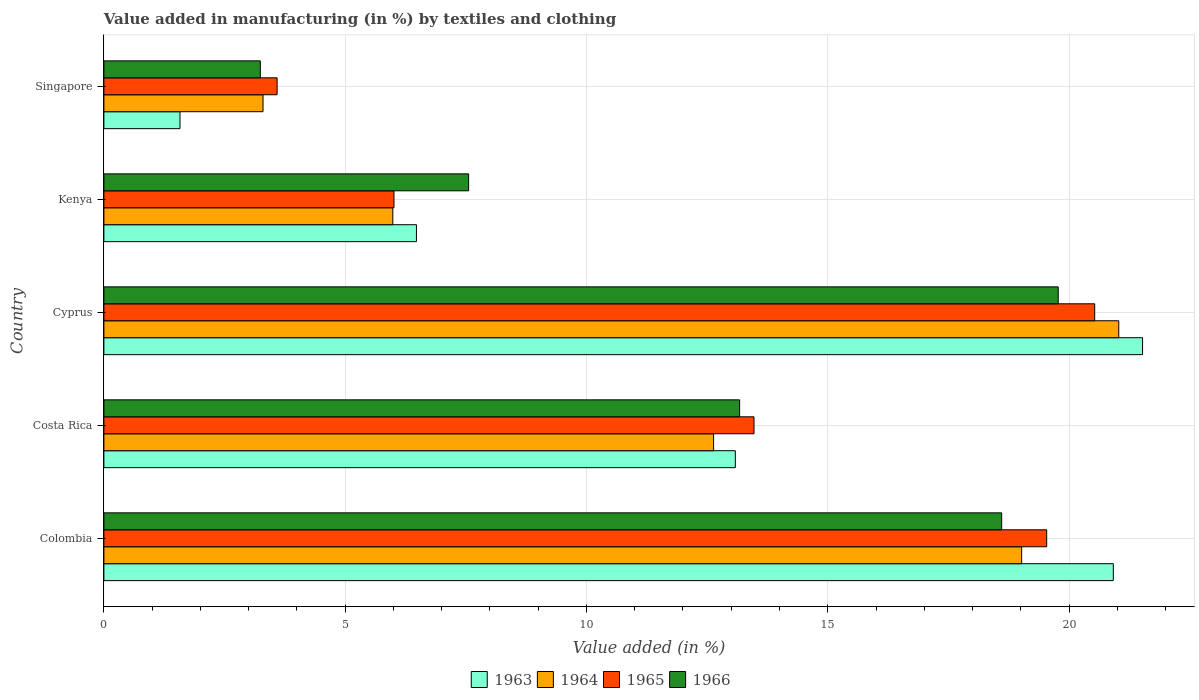How many different coloured bars are there?
Give a very brief answer. 4. How many groups of bars are there?
Your answer should be very brief. 5. Are the number of bars on each tick of the Y-axis equal?
Provide a succinct answer. Yes. How many bars are there on the 1st tick from the top?
Keep it short and to the point. 4. How many bars are there on the 3rd tick from the bottom?
Provide a succinct answer. 4. What is the percentage of value added in manufacturing by textiles and clothing in 1964 in Colombia?
Your response must be concise. 19.02. Across all countries, what is the maximum percentage of value added in manufacturing by textiles and clothing in 1965?
Keep it short and to the point. 20.53. Across all countries, what is the minimum percentage of value added in manufacturing by textiles and clothing in 1966?
Offer a very short reply. 3.24. In which country was the percentage of value added in manufacturing by textiles and clothing in 1965 maximum?
Your response must be concise. Cyprus. In which country was the percentage of value added in manufacturing by textiles and clothing in 1964 minimum?
Offer a terse response. Singapore. What is the total percentage of value added in manufacturing by textiles and clothing in 1966 in the graph?
Give a very brief answer. 62.35. What is the difference between the percentage of value added in manufacturing by textiles and clothing in 1966 in Colombia and that in Singapore?
Make the answer very short. 15.36. What is the difference between the percentage of value added in manufacturing by textiles and clothing in 1964 in Kenya and the percentage of value added in manufacturing by textiles and clothing in 1965 in Singapore?
Your response must be concise. 2.4. What is the average percentage of value added in manufacturing by textiles and clothing in 1964 per country?
Your answer should be compact. 12.39. What is the difference between the percentage of value added in manufacturing by textiles and clothing in 1966 and percentage of value added in manufacturing by textiles and clothing in 1964 in Kenya?
Make the answer very short. 1.57. In how many countries, is the percentage of value added in manufacturing by textiles and clothing in 1966 greater than 1 %?
Offer a very short reply. 5. What is the ratio of the percentage of value added in manufacturing by textiles and clothing in 1964 in Kenya to that in Singapore?
Provide a succinct answer. 1.82. What is the difference between the highest and the second highest percentage of value added in manufacturing by textiles and clothing in 1965?
Ensure brevity in your answer.  0.99. What is the difference between the highest and the lowest percentage of value added in manufacturing by textiles and clothing in 1963?
Offer a terse response. 19.95. In how many countries, is the percentage of value added in manufacturing by textiles and clothing in 1963 greater than the average percentage of value added in manufacturing by textiles and clothing in 1963 taken over all countries?
Provide a succinct answer. 3. Is the sum of the percentage of value added in manufacturing by textiles and clothing in 1964 in Kenya and Singapore greater than the maximum percentage of value added in manufacturing by textiles and clothing in 1966 across all countries?
Your answer should be compact. No. What does the 3rd bar from the top in Singapore represents?
Your answer should be very brief. 1964. What does the 4th bar from the bottom in Kenya represents?
Keep it short and to the point. 1966. How many bars are there?
Make the answer very short. 20. How many countries are there in the graph?
Provide a succinct answer. 5. What is the difference between two consecutive major ticks on the X-axis?
Ensure brevity in your answer.  5. Does the graph contain any zero values?
Provide a short and direct response. No. Does the graph contain grids?
Your answer should be very brief. Yes. Where does the legend appear in the graph?
Your answer should be very brief. Bottom center. How many legend labels are there?
Your answer should be very brief. 4. What is the title of the graph?
Give a very brief answer. Value added in manufacturing (in %) by textiles and clothing. Does "1983" appear as one of the legend labels in the graph?
Make the answer very short. No. What is the label or title of the X-axis?
Provide a succinct answer. Value added (in %). What is the Value added (in %) of 1963 in Colombia?
Your response must be concise. 20.92. What is the Value added (in %) of 1964 in Colombia?
Provide a succinct answer. 19.02. What is the Value added (in %) in 1965 in Colombia?
Make the answer very short. 19.54. What is the Value added (in %) in 1966 in Colombia?
Your answer should be very brief. 18.6. What is the Value added (in %) in 1963 in Costa Rica?
Ensure brevity in your answer.  13.08. What is the Value added (in %) of 1964 in Costa Rica?
Give a very brief answer. 12.63. What is the Value added (in %) in 1965 in Costa Rica?
Ensure brevity in your answer.  13.47. What is the Value added (in %) in 1966 in Costa Rica?
Provide a short and direct response. 13.17. What is the Value added (in %) of 1963 in Cyprus?
Keep it short and to the point. 21.52. What is the Value added (in %) in 1964 in Cyprus?
Ensure brevity in your answer.  21.03. What is the Value added (in %) of 1965 in Cyprus?
Your answer should be very brief. 20.53. What is the Value added (in %) in 1966 in Cyprus?
Offer a terse response. 19.78. What is the Value added (in %) of 1963 in Kenya?
Keep it short and to the point. 6.48. What is the Value added (in %) in 1964 in Kenya?
Make the answer very short. 5.99. What is the Value added (in %) of 1965 in Kenya?
Keep it short and to the point. 6.01. What is the Value added (in %) of 1966 in Kenya?
Your response must be concise. 7.56. What is the Value added (in %) in 1963 in Singapore?
Provide a short and direct response. 1.58. What is the Value added (in %) in 1964 in Singapore?
Make the answer very short. 3.3. What is the Value added (in %) of 1965 in Singapore?
Ensure brevity in your answer.  3.59. What is the Value added (in %) of 1966 in Singapore?
Offer a terse response. 3.24. Across all countries, what is the maximum Value added (in %) of 1963?
Provide a succinct answer. 21.52. Across all countries, what is the maximum Value added (in %) of 1964?
Keep it short and to the point. 21.03. Across all countries, what is the maximum Value added (in %) of 1965?
Offer a very short reply. 20.53. Across all countries, what is the maximum Value added (in %) in 1966?
Provide a succinct answer. 19.78. Across all countries, what is the minimum Value added (in %) of 1963?
Give a very brief answer. 1.58. Across all countries, what is the minimum Value added (in %) in 1964?
Your response must be concise. 3.3. Across all countries, what is the minimum Value added (in %) in 1965?
Ensure brevity in your answer.  3.59. Across all countries, what is the minimum Value added (in %) in 1966?
Your answer should be compact. 3.24. What is the total Value added (in %) in 1963 in the graph?
Your answer should be very brief. 63.58. What is the total Value added (in %) of 1964 in the graph?
Provide a short and direct response. 61.97. What is the total Value added (in %) in 1965 in the graph?
Provide a short and direct response. 63.14. What is the total Value added (in %) of 1966 in the graph?
Give a very brief answer. 62.35. What is the difference between the Value added (in %) of 1963 in Colombia and that in Costa Rica?
Offer a very short reply. 7.83. What is the difference between the Value added (in %) in 1964 in Colombia and that in Costa Rica?
Provide a short and direct response. 6.38. What is the difference between the Value added (in %) in 1965 in Colombia and that in Costa Rica?
Your response must be concise. 6.06. What is the difference between the Value added (in %) in 1966 in Colombia and that in Costa Rica?
Your response must be concise. 5.43. What is the difference between the Value added (in %) of 1963 in Colombia and that in Cyprus?
Offer a very short reply. -0.61. What is the difference between the Value added (in %) of 1964 in Colombia and that in Cyprus?
Provide a short and direct response. -2.01. What is the difference between the Value added (in %) in 1965 in Colombia and that in Cyprus?
Give a very brief answer. -0.99. What is the difference between the Value added (in %) in 1966 in Colombia and that in Cyprus?
Give a very brief answer. -1.17. What is the difference between the Value added (in %) in 1963 in Colombia and that in Kenya?
Give a very brief answer. 14.44. What is the difference between the Value added (in %) of 1964 in Colombia and that in Kenya?
Make the answer very short. 13.03. What is the difference between the Value added (in %) in 1965 in Colombia and that in Kenya?
Offer a very short reply. 13.53. What is the difference between the Value added (in %) in 1966 in Colombia and that in Kenya?
Make the answer very short. 11.05. What is the difference between the Value added (in %) in 1963 in Colombia and that in Singapore?
Offer a terse response. 19.34. What is the difference between the Value added (in %) in 1964 in Colombia and that in Singapore?
Your answer should be compact. 15.72. What is the difference between the Value added (in %) in 1965 in Colombia and that in Singapore?
Give a very brief answer. 15.95. What is the difference between the Value added (in %) in 1966 in Colombia and that in Singapore?
Offer a very short reply. 15.36. What is the difference between the Value added (in %) in 1963 in Costa Rica and that in Cyprus?
Your answer should be very brief. -8.44. What is the difference between the Value added (in %) of 1964 in Costa Rica and that in Cyprus?
Offer a terse response. -8.4. What is the difference between the Value added (in %) of 1965 in Costa Rica and that in Cyprus?
Keep it short and to the point. -7.06. What is the difference between the Value added (in %) of 1966 in Costa Rica and that in Cyprus?
Provide a succinct answer. -6.6. What is the difference between the Value added (in %) of 1963 in Costa Rica and that in Kenya?
Offer a terse response. 6.61. What is the difference between the Value added (in %) in 1964 in Costa Rica and that in Kenya?
Offer a very short reply. 6.65. What is the difference between the Value added (in %) in 1965 in Costa Rica and that in Kenya?
Provide a succinct answer. 7.46. What is the difference between the Value added (in %) in 1966 in Costa Rica and that in Kenya?
Provide a short and direct response. 5.62. What is the difference between the Value added (in %) of 1963 in Costa Rica and that in Singapore?
Your answer should be compact. 11.51. What is the difference between the Value added (in %) in 1964 in Costa Rica and that in Singapore?
Offer a very short reply. 9.34. What is the difference between the Value added (in %) in 1965 in Costa Rica and that in Singapore?
Offer a very short reply. 9.88. What is the difference between the Value added (in %) in 1966 in Costa Rica and that in Singapore?
Provide a short and direct response. 9.93. What is the difference between the Value added (in %) of 1963 in Cyprus and that in Kenya?
Offer a terse response. 15.05. What is the difference between the Value added (in %) in 1964 in Cyprus and that in Kenya?
Give a very brief answer. 15.04. What is the difference between the Value added (in %) of 1965 in Cyprus and that in Kenya?
Your answer should be very brief. 14.52. What is the difference between the Value added (in %) in 1966 in Cyprus and that in Kenya?
Give a very brief answer. 12.22. What is the difference between the Value added (in %) in 1963 in Cyprus and that in Singapore?
Your answer should be compact. 19.95. What is the difference between the Value added (in %) of 1964 in Cyprus and that in Singapore?
Provide a short and direct response. 17.73. What is the difference between the Value added (in %) in 1965 in Cyprus and that in Singapore?
Keep it short and to the point. 16.94. What is the difference between the Value added (in %) in 1966 in Cyprus and that in Singapore?
Offer a terse response. 16.53. What is the difference between the Value added (in %) of 1963 in Kenya and that in Singapore?
Provide a short and direct response. 4.9. What is the difference between the Value added (in %) in 1964 in Kenya and that in Singapore?
Keep it short and to the point. 2.69. What is the difference between the Value added (in %) in 1965 in Kenya and that in Singapore?
Provide a short and direct response. 2.42. What is the difference between the Value added (in %) in 1966 in Kenya and that in Singapore?
Offer a very short reply. 4.32. What is the difference between the Value added (in %) of 1963 in Colombia and the Value added (in %) of 1964 in Costa Rica?
Keep it short and to the point. 8.28. What is the difference between the Value added (in %) in 1963 in Colombia and the Value added (in %) in 1965 in Costa Rica?
Your answer should be compact. 7.44. What is the difference between the Value added (in %) in 1963 in Colombia and the Value added (in %) in 1966 in Costa Rica?
Your answer should be compact. 7.74. What is the difference between the Value added (in %) of 1964 in Colombia and the Value added (in %) of 1965 in Costa Rica?
Keep it short and to the point. 5.55. What is the difference between the Value added (in %) of 1964 in Colombia and the Value added (in %) of 1966 in Costa Rica?
Ensure brevity in your answer.  5.84. What is the difference between the Value added (in %) of 1965 in Colombia and the Value added (in %) of 1966 in Costa Rica?
Your answer should be compact. 6.36. What is the difference between the Value added (in %) in 1963 in Colombia and the Value added (in %) in 1964 in Cyprus?
Your answer should be very brief. -0.11. What is the difference between the Value added (in %) in 1963 in Colombia and the Value added (in %) in 1965 in Cyprus?
Offer a terse response. 0.39. What is the difference between the Value added (in %) in 1963 in Colombia and the Value added (in %) in 1966 in Cyprus?
Your response must be concise. 1.14. What is the difference between the Value added (in %) of 1964 in Colombia and the Value added (in %) of 1965 in Cyprus?
Your response must be concise. -1.51. What is the difference between the Value added (in %) in 1964 in Colombia and the Value added (in %) in 1966 in Cyprus?
Your response must be concise. -0.76. What is the difference between the Value added (in %) in 1965 in Colombia and the Value added (in %) in 1966 in Cyprus?
Ensure brevity in your answer.  -0.24. What is the difference between the Value added (in %) in 1963 in Colombia and the Value added (in %) in 1964 in Kenya?
Make the answer very short. 14.93. What is the difference between the Value added (in %) of 1963 in Colombia and the Value added (in %) of 1965 in Kenya?
Provide a succinct answer. 14.91. What is the difference between the Value added (in %) of 1963 in Colombia and the Value added (in %) of 1966 in Kenya?
Keep it short and to the point. 13.36. What is the difference between the Value added (in %) in 1964 in Colombia and the Value added (in %) in 1965 in Kenya?
Your response must be concise. 13.01. What is the difference between the Value added (in %) in 1964 in Colombia and the Value added (in %) in 1966 in Kenya?
Give a very brief answer. 11.46. What is the difference between the Value added (in %) of 1965 in Colombia and the Value added (in %) of 1966 in Kenya?
Make the answer very short. 11.98. What is the difference between the Value added (in %) of 1963 in Colombia and the Value added (in %) of 1964 in Singapore?
Your answer should be compact. 17.62. What is the difference between the Value added (in %) of 1963 in Colombia and the Value added (in %) of 1965 in Singapore?
Provide a succinct answer. 17.33. What is the difference between the Value added (in %) of 1963 in Colombia and the Value added (in %) of 1966 in Singapore?
Offer a very short reply. 17.68. What is the difference between the Value added (in %) in 1964 in Colombia and the Value added (in %) in 1965 in Singapore?
Provide a succinct answer. 15.43. What is the difference between the Value added (in %) in 1964 in Colombia and the Value added (in %) in 1966 in Singapore?
Offer a terse response. 15.78. What is the difference between the Value added (in %) of 1965 in Colombia and the Value added (in %) of 1966 in Singapore?
Your answer should be compact. 16.3. What is the difference between the Value added (in %) in 1963 in Costa Rica and the Value added (in %) in 1964 in Cyprus?
Offer a terse response. -7.95. What is the difference between the Value added (in %) in 1963 in Costa Rica and the Value added (in %) in 1965 in Cyprus?
Offer a terse response. -7.45. What is the difference between the Value added (in %) in 1963 in Costa Rica and the Value added (in %) in 1966 in Cyprus?
Your answer should be compact. -6.69. What is the difference between the Value added (in %) in 1964 in Costa Rica and the Value added (in %) in 1965 in Cyprus?
Ensure brevity in your answer.  -7.9. What is the difference between the Value added (in %) of 1964 in Costa Rica and the Value added (in %) of 1966 in Cyprus?
Make the answer very short. -7.14. What is the difference between the Value added (in %) in 1965 in Costa Rica and the Value added (in %) in 1966 in Cyprus?
Provide a short and direct response. -6.3. What is the difference between the Value added (in %) of 1963 in Costa Rica and the Value added (in %) of 1964 in Kenya?
Provide a short and direct response. 7.1. What is the difference between the Value added (in %) in 1963 in Costa Rica and the Value added (in %) in 1965 in Kenya?
Offer a terse response. 7.07. What is the difference between the Value added (in %) of 1963 in Costa Rica and the Value added (in %) of 1966 in Kenya?
Offer a terse response. 5.53. What is the difference between the Value added (in %) of 1964 in Costa Rica and the Value added (in %) of 1965 in Kenya?
Make the answer very short. 6.62. What is the difference between the Value added (in %) in 1964 in Costa Rica and the Value added (in %) in 1966 in Kenya?
Keep it short and to the point. 5.08. What is the difference between the Value added (in %) of 1965 in Costa Rica and the Value added (in %) of 1966 in Kenya?
Your answer should be very brief. 5.91. What is the difference between the Value added (in %) in 1963 in Costa Rica and the Value added (in %) in 1964 in Singapore?
Give a very brief answer. 9.79. What is the difference between the Value added (in %) of 1963 in Costa Rica and the Value added (in %) of 1965 in Singapore?
Keep it short and to the point. 9.5. What is the difference between the Value added (in %) of 1963 in Costa Rica and the Value added (in %) of 1966 in Singapore?
Provide a succinct answer. 9.84. What is the difference between the Value added (in %) in 1964 in Costa Rica and the Value added (in %) in 1965 in Singapore?
Give a very brief answer. 9.04. What is the difference between the Value added (in %) of 1964 in Costa Rica and the Value added (in %) of 1966 in Singapore?
Ensure brevity in your answer.  9.39. What is the difference between the Value added (in %) in 1965 in Costa Rica and the Value added (in %) in 1966 in Singapore?
Your answer should be very brief. 10.23. What is the difference between the Value added (in %) in 1963 in Cyprus and the Value added (in %) in 1964 in Kenya?
Provide a succinct answer. 15.54. What is the difference between the Value added (in %) of 1963 in Cyprus and the Value added (in %) of 1965 in Kenya?
Provide a short and direct response. 15.51. What is the difference between the Value added (in %) of 1963 in Cyprus and the Value added (in %) of 1966 in Kenya?
Offer a very short reply. 13.97. What is the difference between the Value added (in %) in 1964 in Cyprus and the Value added (in %) in 1965 in Kenya?
Provide a succinct answer. 15.02. What is the difference between the Value added (in %) of 1964 in Cyprus and the Value added (in %) of 1966 in Kenya?
Provide a short and direct response. 13.47. What is the difference between the Value added (in %) of 1965 in Cyprus and the Value added (in %) of 1966 in Kenya?
Offer a terse response. 12.97. What is the difference between the Value added (in %) of 1963 in Cyprus and the Value added (in %) of 1964 in Singapore?
Offer a terse response. 18.23. What is the difference between the Value added (in %) of 1963 in Cyprus and the Value added (in %) of 1965 in Singapore?
Your response must be concise. 17.93. What is the difference between the Value added (in %) of 1963 in Cyprus and the Value added (in %) of 1966 in Singapore?
Your answer should be very brief. 18.28. What is the difference between the Value added (in %) in 1964 in Cyprus and the Value added (in %) in 1965 in Singapore?
Give a very brief answer. 17.44. What is the difference between the Value added (in %) of 1964 in Cyprus and the Value added (in %) of 1966 in Singapore?
Your answer should be compact. 17.79. What is the difference between the Value added (in %) of 1965 in Cyprus and the Value added (in %) of 1966 in Singapore?
Your response must be concise. 17.29. What is the difference between the Value added (in %) in 1963 in Kenya and the Value added (in %) in 1964 in Singapore?
Offer a very short reply. 3.18. What is the difference between the Value added (in %) of 1963 in Kenya and the Value added (in %) of 1965 in Singapore?
Your answer should be very brief. 2.89. What is the difference between the Value added (in %) in 1963 in Kenya and the Value added (in %) in 1966 in Singapore?
Your response must be concise. 3.24. What is the difference between the Value added (in %) in 1964 in Kenya and the Value added (in %) in 1965 in Singapore?
Offer a terse response. 2.4. What is the difference between the Value added (in %) in 1964 in Kenya and the Value added (in %) in 1966 in Singapore?
Ensure brevity in your answer.  2.75. What is the difference between the Value added (in %) of 1965 in Kenya and the Value added (in %) of 1966 in Singapore?
Your response must be concise. 2.77. What is the average Value added (in %) in 1963 per country?
Provide a succinct answer. 12.72. What is the average Value added (in %) of 1964 per country?
Provide a succinct answer. 12.39. What is the average Value added (in %) in 1965 per country?
Your response must be concise. 12.63. What is the average Value added (in %) of 1966 per country?
Your answer should be very brief. 12.47. What is the difference between the Value added (in %) in 1963 and Value added (in %) in 1964 in Colombia?
Your answer should be compact. 1.9. What is the difference between the Value added (in %) in 1963 and Value added (in %) in 1965 in Colombia?
Your response must be concise. 1.38. What is the difference between the Value added (in %) in 1963 and Value added (in %) in 1966 in Colombia?
Offer a very short reply. 2.31. What is the difference between the Value added (in %) in 1964 and Value added (in %) in 1965 in Colombia?
Offer a terse response. -0.52. What is the difference between the Value added (in %) of 1964 and Value added (in %) of 1966 in Colombia?
Your response must be concise. 0.41. What is the difference between the Value added (in %) of 1965 and Value added (in %) of 1966 in Colombia?
Keep it short and to the point. 0.93. What is the difference between the Value added (in %) of 1963 and Value added (in %) of 1964 in Costa Rica?
Keep it short and to the point. 0.45. What is the difference between the Value added (in %) of 1963 and Value added (in %) of 1965 in Costa Rica?
Keep it short and to the point. -0.39. What is the difference between the Value added (in %) in 1963 and Value added (in %) in 1966 in Costa Rica?
Your answer should be compact. -0.09. What is the difference between the Value added (in %) in 1964 and Value added (in %) in 1965 in Costa Rica?
Ensure brevity in your answer.  -0.84. What is the difference between the Value added (in %) of 1964 and Value added (in %) of 1966 in Costa Rica?
Give a very brief answer. -0.54. What is the difference between the Value added (in %) in 1965 and Value added (in %) in 1966 in Costa Rica?
Your answer should be compact. 0.3. What is the difference between the Value added (in %) in 1963 and Value added (in %) in 1964 in Cyprus?
Make the answer very short. 0.49. What is the difference between the Value added (in %) in 1963 and Value added (in %) in 1965 in Cyprus?
Offer a terse response. 0.99. What is the difference between the Value added (in %) in 1963 and Value added (in %) in 1966 in Cyprus?
Offer a terse response. 1.75. What is the difference between the Value added (in %) in 1964 and Value added (in %) in 1965 in Cyprus?
Ensure brevity in your answer.  0.5. What is the difference between the Value added (in %) of 1964 and Value added (in %) of 1966 in Cyprus?
Provide a succinct answer. 1.25. What is the difference between the Value added (in %) of 1965 and Value added (in %) of 1966 in Cyprus?
Give a very brief answer. 0.76. What is the difference between the Value added (in %) of 1963 and Value added (in %) of 1964 in Kenya?
Provide a short and direct response. 0.49. What is the difference between the Value added (in %) in 1963 and Value added (in %) in 1965 in Kenya?
Give a very brief answer. 0.47. What is the difference between the Value added (in %) of 1963 and Value added (in %) of 1966 in Kenya?
Give a very brief answer. -1.08. What is the difference between the Value added (in %) of 1964 and Value added (in %) of 1965 in Kenya?
Your answer should be very brief. -0.02. What is the difference between the Value added (in %) in 1964 and Value added (in %) in 1966 in Kenya?
Make the answer very short. -1.57. What is the difference between the Value added (in %) in 1965 and Value added (in %) in 1966 in Kenya?
Make the answer very short. -1.55. What is the difference between the Value added (in %) in 1963 and Value added (in %) in 1964 in Singapore?
Give a very brief answer. -1.72. What is the difference between the Value added (in %) of 1963 and Value added (in %) of 1965 in Singapore?
Provide a short and direct response. -2.01. What is the difference between the Value added (in %) of 1963 and Value added (in %) of 1966 in Singapore?
Your answer should be compact. -1.66. What is the difference between the Value added (in %) in 1964 and Value added (in %) in 1965 in Singapore?
Your answer should be compact. -0.29. What is the difference between the Value added (in %) in 1964 and Value added (in %) in 1966 in Singapore?
Make the answer very short. 0.06. What is the difference between the Value added (in %) in 1965 and Value added (in %) in 1966 in Singapore?
Ensure brevity in your answer.  0.35. What is the ratio of the Value added (in %) of 1963 in Colombia to that in Costa Rica?
Give a very brief answer. 1.6. What is the ratio of the Value added (in %) of 1964 in Colombia to that in Costa Rica?
Make the answer very short. 1.51. What is the ratio of the Value added (in %) in 1965 in Colombia to that in Costa Rica?
Provide a short and direct response. 1.45. What is the ratio of the Value added (in %) of 1966 in Colombia to that in Costa Rica?
Provide a short and direct response. 1.41. What is the ratio of the Value added (in %) of 1963 in Colombia to that in Cyprus?
Give a very brief answer. 0.97. What is the ratio of the Value added (in %) in 1964 in Colombia to that in Cyprus?
Provide a short and direct response. 0.9. What is the ratio of the Value added (in %) in 1965 in Colombia to that in Cyprus?
Make the answer very short. 0.95. What is the ratio of the Value added (in %) of 1966 in Colombia to that in Cyprus?
Your response must be concise. 0.94. What is the ratio of the Value added (in %) in 1963 in Colombia to that in Kenya?
Offer a very short reply. 3.23. What is the ratio of the Value added (in %) of 1964 in Colombia to that in Kenya?
Provide a short and direct response. 3.18. What is the ratio of the Value added (in %) of 1966 in Colombia to that in Kenya?
Make the answer very short. 2.46. What is the ratio of the Value added (in %) of 1963 in Colombia to that in Singapore?
Ensure brevity in your answer.  13.26. What is the ratio of the Value added (in %) of 1964 in Colombia to that in Singapore?
Offer a very short reply. 5.77. What is the ratio of the Value added (in %) in 1965 in Colombia to that in Singapore?
Provide a short and direct response. 5.44. What is the ratio of the Value added (in %) in 1966 in Colombia to that in Singapore?
Ensure brevity in your answer.  5.74. What is the ratio of the Value added (in %) of 1963 in Costa Rica to that in Cyprus?
Provide a succinct answer. 0.61. What is the ratio of the Value added (in %) of 1964 in Costa Rica to that in Cyprus?
Your answer should be compact. 0.6. What is the ratio of the Value added (in %) of 1965 in Costa Rica to that in Cyprus?
Offer a very short reply. 0.66. What is the ratio of the Value added (in %) in 1966 in Costa Rica to that in Cyprus?
Provide a short and direct response. 0.67. What is the ratio of the Value added (in %) in 1963 in Costa Rica to that in Kenya?
Provide a short and direct response. 2.02. What is the ratio of the Value added (in %) of 1964 in Costa Rica to that in Kenya?
Make the answer very short. 2.11. What is the ratio of the Value added (in %) of 1965 in Costa Rica to that in Kenya?
Your answer should be very brief. 2.24. What is the ratio of the Value added (in %) of 1966 in Costa Rica to that in Kenya?
Make the answer very short. 1.74. What is the ratio of the Value added (in %) of 1963 in Costa Rica to that in Singapore?
Your answer should be very brief. 8.3. What is the ratio of the Value added (in %) in 1964 in Costa Rica to that in Singapore?
Give a very brief answer. 3.83. What is the ratio of the Value added (in %) in 1965 in Costa Rica to that in Singapore?
Your response must be concise. 3.75. What is the ratio of the Value added (in %) in 1966 in Costa Rica to that in Singapore?
Keep it short and to the point. 4.06. What is the ratio of the Value added (in %) in 1963 in Cyprus to that in Kenya?
Offer a very short reply. 3.32. What is the ratio of the Value added (in %) in 1964 in Cyprus to that in Kenya?
Give a very brief answer. 3.51. What is the ratio of the Value added (in %) of 1965 in Cyprus to that in Kenya?
Make the answer very short. 3.42. What is the ratio of the Value added (in %) of 1966 in Cyprus to that in Kenya?
Make the answer very short. 2.62. What is the ratio of the Value added (in %) in 1963 in Cyprus to that in Singapore?
Your answer should be very brief. 13.65. What is the ratio of the Value added (in %) of 1964 in Cyprus to that in Singapore?
Keep it short and to the point. 6.38. What is the ratio of the Value added (in %) of 1965 in Cyprus to that in Singapore?
Provide a succinct answer. 5.72. What is the ratio of the Value added (in %) of 1966 in Cyprus to that in Singapore?
Give a very brief answer. 6.1. What is the ratio of the Value added (in %) in 1963 in Kenya to that in Singapore?
Your response must be concise. 4.11. What is the ratio of the Value added (in %) of 1964 in Kenya to that in Singapore?
Provide a succinct answer. 1.82. What is the ratio of the Value added (in %) of 1965 in Kenya to that in Singapore?
Your answer should be very brief. 1.67. What is the ratio of the Value added (in %) in 1966 in Kenya to that in Singapore?
Offer a very short reply. 2.33. What is the difference between the highest and the second highest Value added (in %) of 1963?
Give a very brief answer. 0.61. What is the difference between the highest and the second highest Value added (in %) in 1964?
Offer a terse response. 2.01. What is the difference between the highest and the second highest Value added (in %) in 1966?
Provide a short and direct response. 1.17. What is the difference between the highest and the lowest Value added (in %) in 1963?
Give a very brief answer. 19.95. What is the difference between the highest and the lowest Value added (in %) in 1964?
Offer a terse response. 17.73. What is the difference between the highest and the lowest Value added (in %) of 1965?
Give a very brief answer. 16.94. What is the difference between the highest and the lowest Value added (in %) in 1966?
Your answer should be compact. 16.53. 